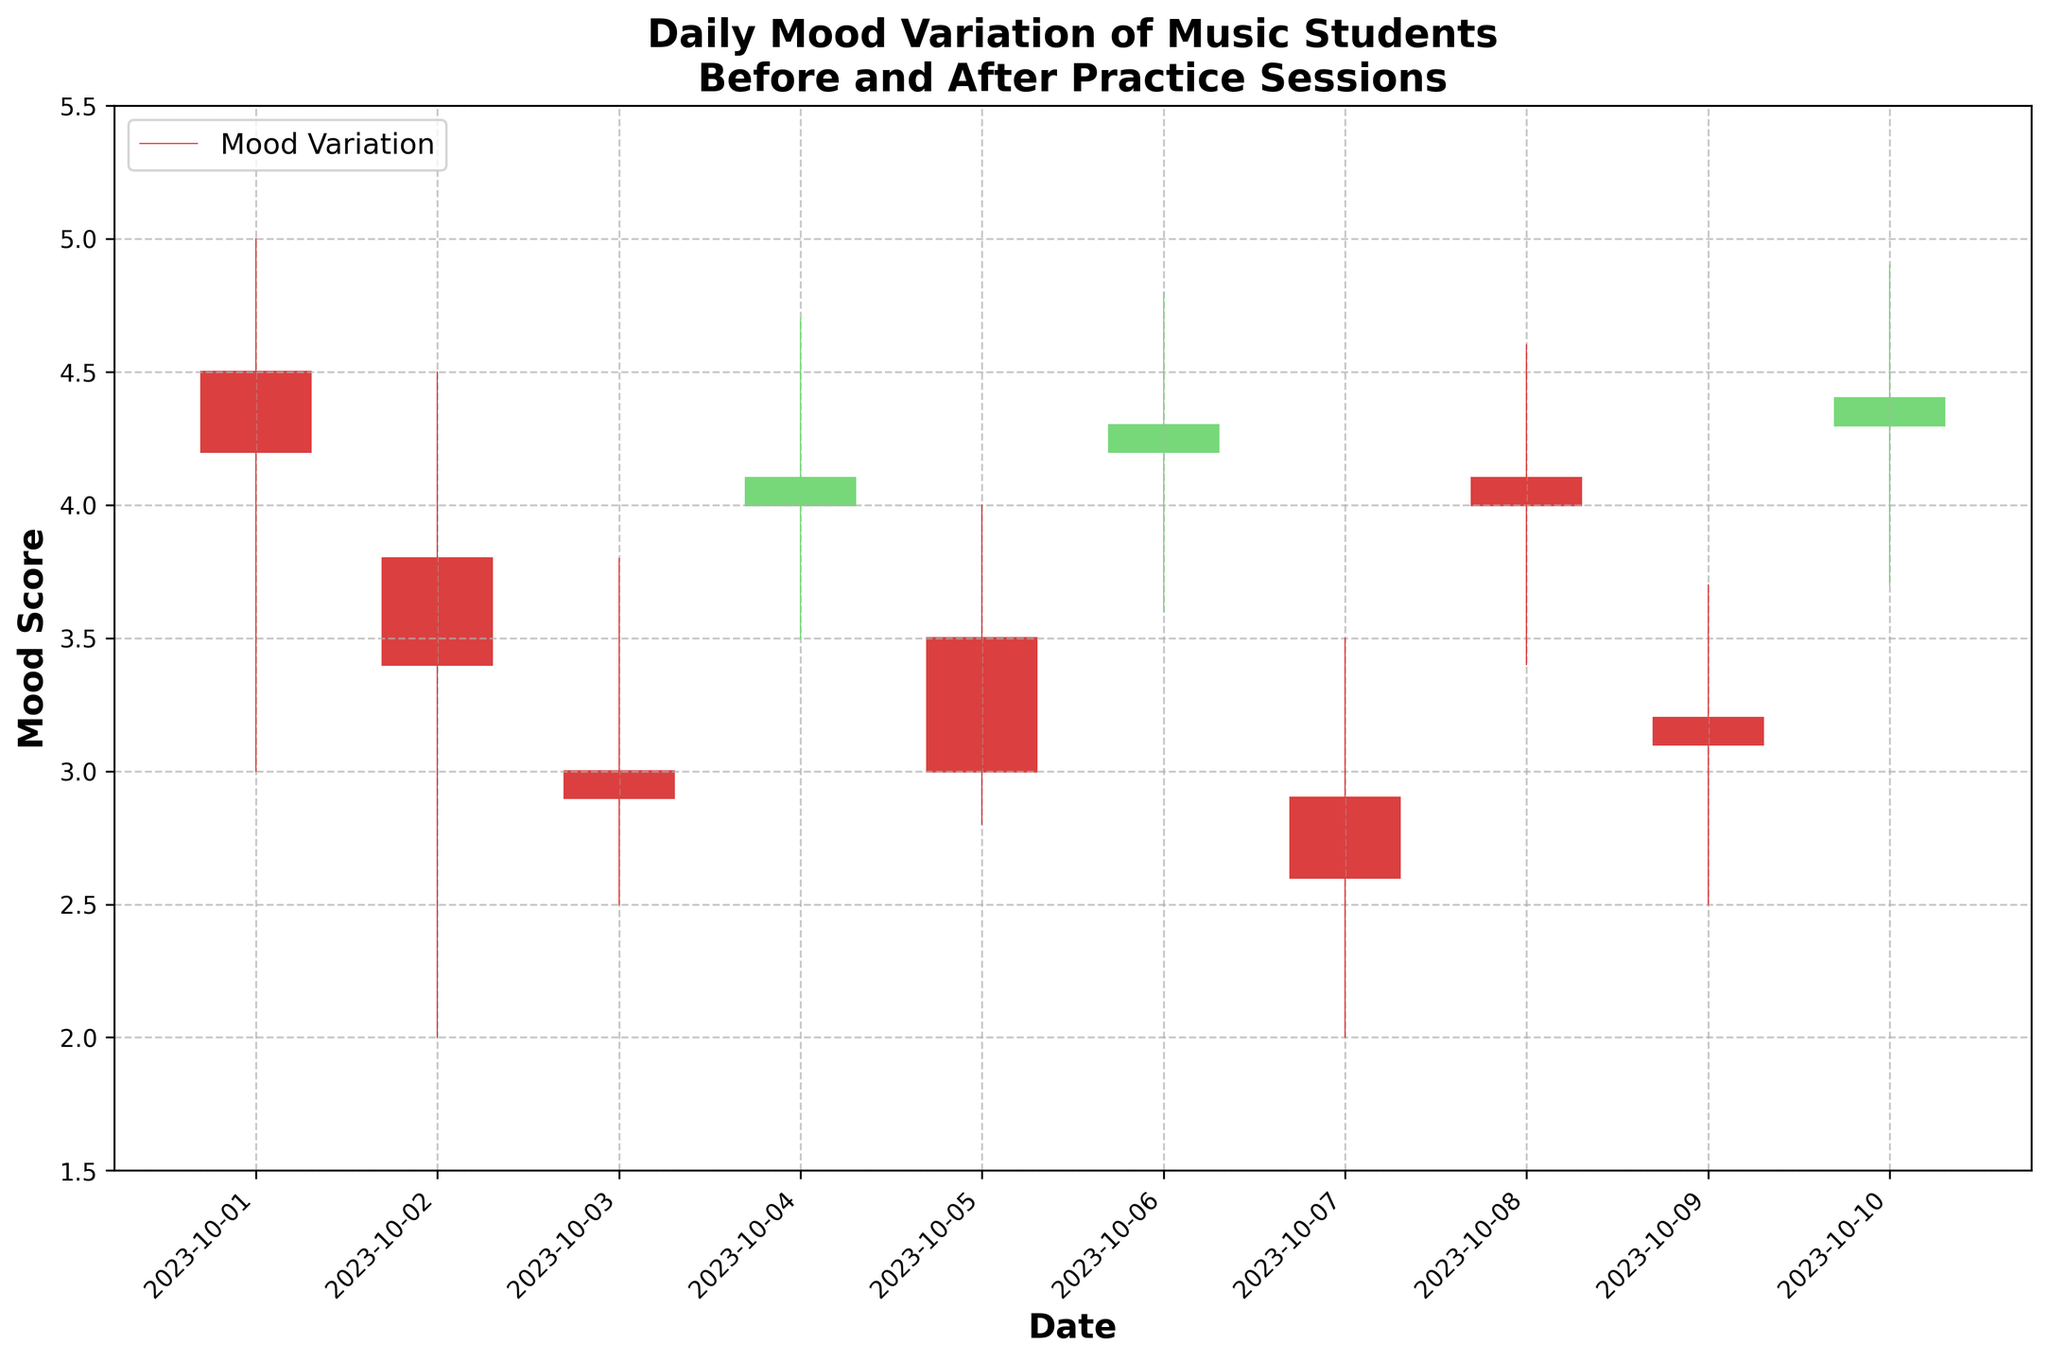What is the title of the plot? The title is located at the top of the plot and reads "Daily Mood Variation of Music Students Before and After Practice Sessions".
Answer: Daily Mood Variation of Music Students Before and After Practice Sessions What period does the data cover? The x-axis displays dates, and the range spans from 2023-10-01 to 2023-10-10.
Answer: 2023-10-01 to 2023-10-10 How many days report a closing mood score higher than 4? Identify the days where the closing price (mood score) is greater than 4; these days are 2023-10-01, 2023-10-06, 2023-10-10.
Answer: 3 days What is the lowest mood score recorded during the period? The lowest score can be seen on the y-axis, in the candlestick plot it's marked on 2023-10-02 and 2023-10-07 at a Low of 2.0.
Answer: 2.0 On which date did the highest mood score occur? Scan through the high points of each candle; the highest score was on 2023-10-10 with a score of 4.9.
Answer: 2023-10-10 What's the difference between the highest and lowest closing mood scores? Identify the highest and lowest closing scores, which are 4.4 on 2023-10-10 and 2.6 on 2023-10-07. Subtract the lowest from the highest: 4.4 - 2.6 = 1.8.
Answer: 1.8 How does the mood score trend from October 1st to October 3rd? Check the closing mood scores on these dates: October 1st (4.2), October 2nd (3.4), October 3rd (2.9). The trend is a consistent decrease.
Answer: Decreasing What can be said about mood variation on October 6th compared to October 7th? Compare the candlestick chart of these two dates: on October 6th, the mood fluctuated between 3.6 and 4.8 and closed higher than it opened. On October 7th, the mood varied between 2.0 and 3.5 and closed lower.
Answer: October 6th: Higher fluctuation and positive close, October 7th: Lower fluctuation and negative close How many days show a positive change in mood from the opening to closing? Check candles where the closing score is higher than the opening: October 1st, October 4th, October 6th, October 8th, and October 10th.
Answer: 5 days 